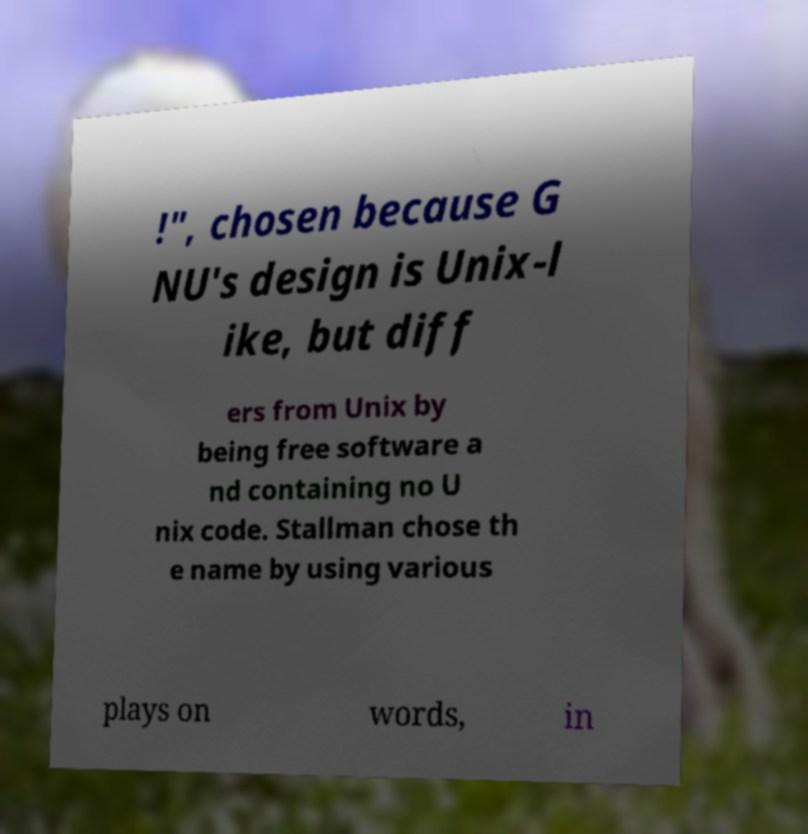Could you assist in decoding the text presented in this image and type it out clearly? !", chosen because G NU's design is Unix-l ike, but diff ers from Unix by being free software a nd containing no U nix code. Stallman chose th e name by using various plays on words, in 